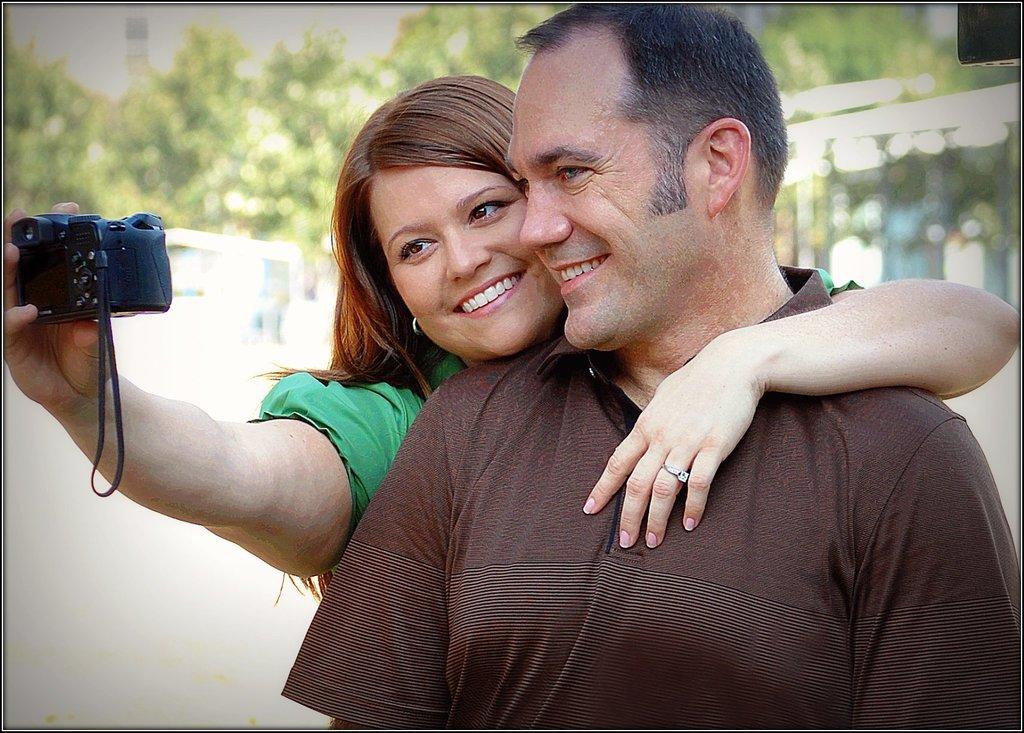Please provide a concise description of this image. there are 2 persons. the person at the front is wearing brown t shirt. the person at the back is holding a camera in her hand. behind them there are trees 